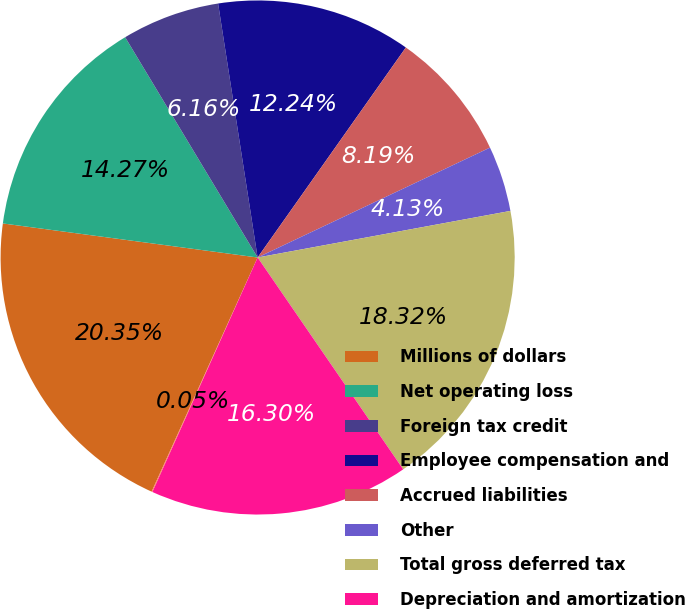Convert chart. <chart><loc_0><loc_0><loc_500><loc_500><pie_chart><fcel>Millions of dollars<fcel>Net operating loss<fcel>Foreign tax credit<fcel>Employee compensation and<fcel>Accrued liabilities<fcel>Other<fcel>Total gross deferred tax<fcel>Depreciation and amortization<fcel>Undistributed foreign earnings<nl><fcel>20.35%<fcel>14.27%<fcel>6.16%<fcel>12.24%<fcel>8.19%<fcel>4.13%<fcel>18.32%<fcel>16.3%<fcel>0.05%<nl></chart> 